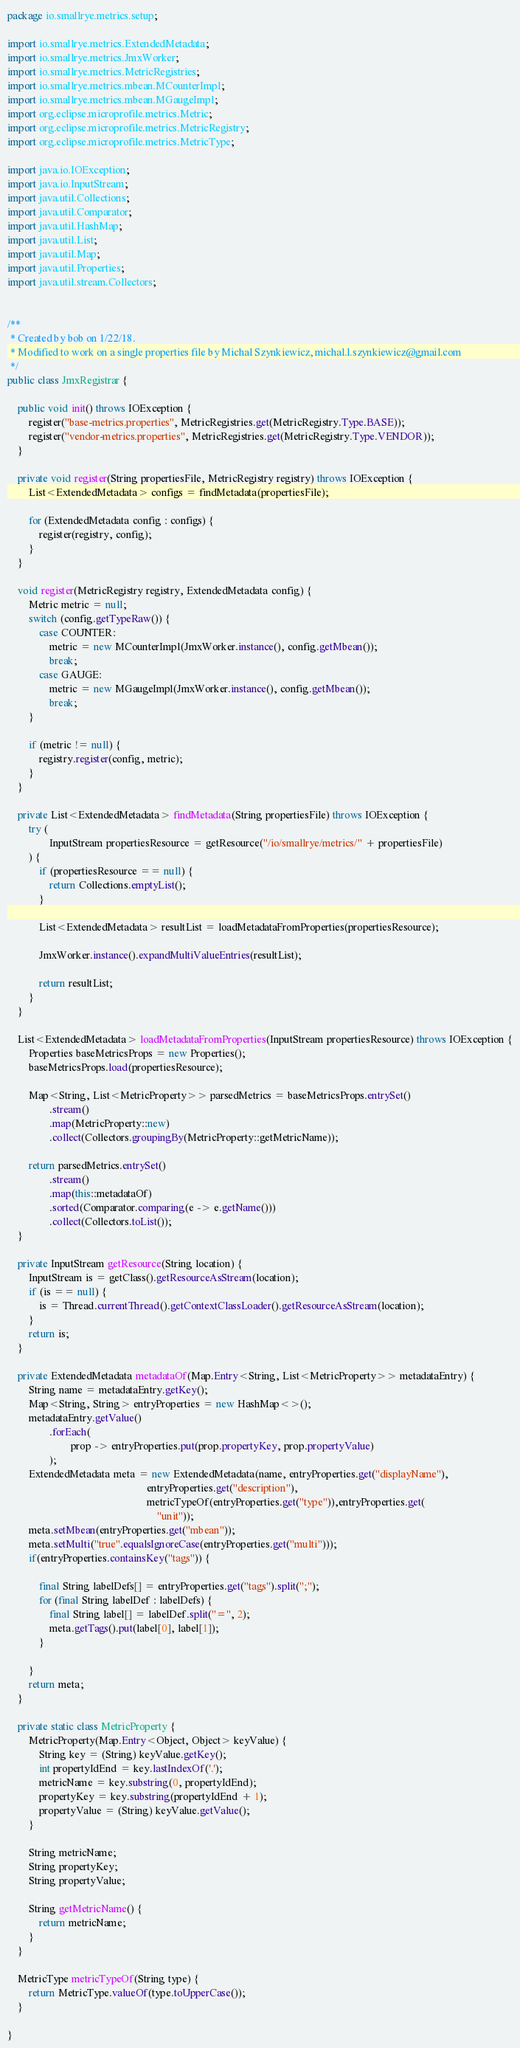<code> <loc_0><loc_0><loc_500><loc_500><_Java_>package io.smallrye.metrics.setup;

import io.smallrye.metrics.ExtendedMetadata;
import io.smallrye.metrics.JmxWorker;
import io.smallrye.metrics.MetricRegistries;
import io.smallrye.metrics.mbean.MCounterImpl;
import io.smallrye.metrics.mbean.MGaugeImpl;
import org.eclipse.microprofile.metrics.Metric;
import org.eclipse.microprofile.metrics.MetricRegistry;
import org.eclipse.microprofile.metrics.MetricType;

import java.io.IOException;
import java.io.InputStream;
import java.util.Collections;
import java.util.Comparator;
import java.util.HashMap;
import java.util.List;
import java.util.Map;
import java.util.Properties;
import java.util.stream.Collectors;


/**
 * Created by bob on 1/22/18.
 * Modified to work on a single properties file by Michal Szynkiewicz, michal.l.szynkiewicz@gmail.com
 */
public class JmxRegistrar {

    public void init() throws IOException {
        register("base-metrics.properties", MetricRegistries.get(MetricRegistry.Type.BASE));
        register("vendor-metrics.properties", MetricRegistries.get(MetricRegistry.Type.VENDOR));
    }

    private void register(String propertiesFile, MetricRegistry registry) throws IOException {
        List<ExtendedMetadata> configs = findMetadata(propertiesFile);

        for (ExtendedMetadata config : configs) {
            register(registry, config);
        }
    }

    void register(MetricRegistry registry, ExtendedMetadata config) {
        Metric metric = null;
        switch (config.getTypeRaw()) {
            case COUNTER:
                metric = new MCounterImpl(JmxWorker.instance(), config.getMbean());
                break;
            case GAUGE:
                metric = new MGaugeImpl(JmxWorker.instance(), config.getMbean());
                break;
        }

        if (metric != null) {
            registry.register(config, metric);
        }
    }

    private List<ExtendedMetadata> findMetadata(String propertiesFile) throws IOException {
        try (
                InputStream propertiesResource = getResource("/io/smallrye/metrics/" + propertiesFile)
        ) {
            if (propertiesResource == null) {
                return Collections.emptyList();
            }

            List<ExtendedMetadata> resultList = loadMetadataFromProperties(propertiesResource);

            JmxWorker.instance().expandMultiValueEntries(resultList);

            return resultList;
        }
    }

    List<ExtendedMetadata> loadMetadataFromProperties(InputStream propertiesResource) throws IOException {
        Properties baseMetricsProps = new Properties();
        baseMetricsProps.load(propertiesResource);

        Map<String, List<MetricProperty>> parsedMetrics = baseMetricsProps.entrySet()
                .stream()
                .map(MetricProperty::new)
                .collect(Collectors.groupingBy(MetricProperty::getMetricName));

        return parsedMetrics.entrySet()
                .stream()
                .map(this::metadataOf)
                .sorted(Comparator.comparing(e -> e.getName()))
                .collect(Collectors.toList());
    }

    private InputStream getResource(String location) {
        InputStream is = getClass().getResourceAsStream(location);
        if (is == null) {
            is = Thread.currentThread().getContextClassLoader().getResourceAsStream(location);
        }
        return is;
    }

    private ExtendedMetadata metadataOf(Map.Entry<String, List<MetricProperty>> metadataEntry) {
        String name = metadataEntry.getKey();
        Map<String, String> entryProperties = new HashMap<>();
        metadataEntry.getValue()
                .forEach(
                        prop -> entryProperties.put(prop.propertyKey, prop.propertyValue)
                );
        ExtendedMetadata meta = new ExtendedMetadata(name, entryProperties.get("displayName"),
                                                     entryProperties.get("description"),
                                                     metricTypeOf(entryProperties.get("type")),entryProperties.get(
                                                         "unit"));
        meta.setMbean(entryProperties.get("mbean"));
        meta.setMulti("true".equalsIgnoreCase(entryProperties.get("multi")));
        if(entryProperties.containsKey("tags")) {

        	final String labelDefs[] = entryProperties.get("tags").split(";");
        	for (final String labelDef : labelDefs) {
        		final String label[] = labelDef.split("=", 2);
				meta.getTags().put(label[0], label[1]);
			}
        	
        }
        return meta;
    }

    private static class MetricProperty {
        MetricProperty(Map.Entry<Object, Object> keyValue) {
            String key = (String) keyValue.getKey();
            int propertyIdEnd = key.lastIndexOf('.');
            metricName = key.substring(0, propertyIdEnd);
            propertyKey = key.substring(propertyIdEnd + 1);
            propertyValue = (String) keyValue.getValue();
        }

        String metricName;
        String propertyKey;
        String propertyValue;

        String getMetricName() {
            return metricName;
        }
    }

    MetricType metricTypeOf(String type) {
        return MetricType.valueOf(type.toUpperCase());
    }

}
</code> 